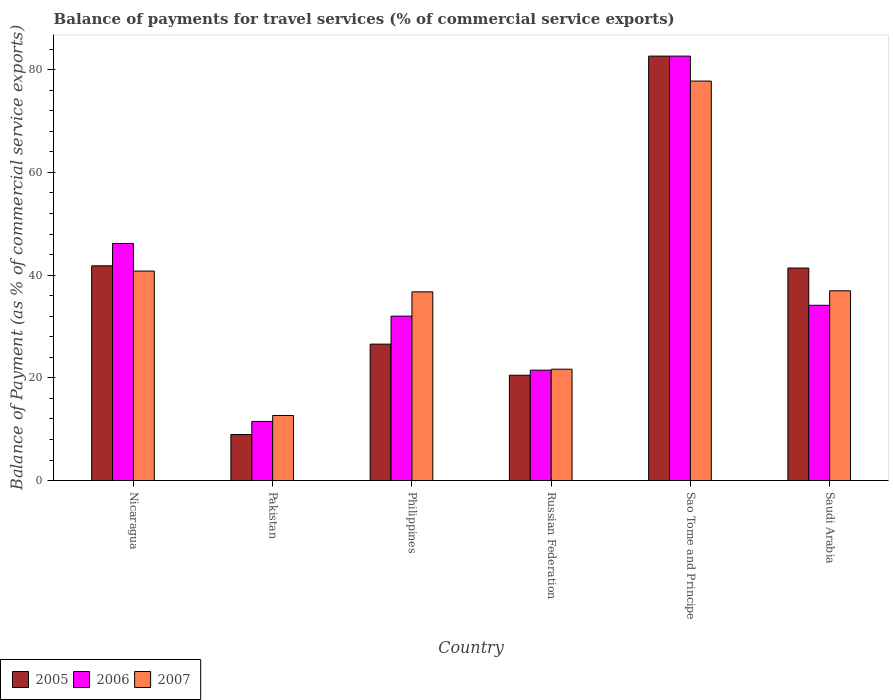How many different coloured bars are there?
Your answer should be compact. 3. How many groups of bars are there?
Ensure brevity in your answer.  6. Are the number of bars per tick equal to the number of legend labels?
Make the answer very short. Yes. How many bars are there on the 3rd tick from the left?
Offer a terse response. 3. How many bars are there on the 6th tick from the right?
Your answer should be very brief. 3. What is the label of the 1st group of bars from the left?
Provide a short and direct response. Nicaragua. In how many cases, is the number of bars for a given country not equal to the number of legend labels?
Offer a very short reply. 0. What is the balance of payments for travel services in 2005 in Saudi Arabia?
Give a very brief answer. 41.38. Across all countries, what is the maximum balance of payments for travel services in 2007?
Your answer should be very brief. 77.78. Across all countries, what is the minimum balance of payments for travel services in 2007?
Give a very brief answer. 12.67. In which country was the balance of payments for travel services in 2006 maximum?
Your answer should be compact. Sao Tome and Principe. What is the total balance of payments for travel services in 2005 in the graph?
Give a very brief answer. 221.87. What is the difference between the balance of payments for travel services in 2006 in Nicaragua and that in Pakistan?
Offer a very short reply. 34.64. What is the difference between the balance of payments for travel services in 2006 in Pakistan and the balance of payments for travel services in 2005 in Russian Federation?
Provide a short and direct response. -9. What is the average balance of payments for travel services in 2005 per country?
Your response must be concise. 36.98. What is the difference between the balance of payments for travel services of/in 2007 and balance of payments for travel services of/in 2005 in Philippines?
Your answer should be compact. 10.18. In how many countries, is the balance of payments for travel services in 2007 greater than 80 %?
Ensure brevity in your answer.  0. What is the ratio of the balance of payments for travel services in 2007 in Russian Federation to that in Saudi Arabia?
Your response must be concise. 0.59. What is the difference between the highest and the second highest balance of payments for travel services in 2005?
Provide a succinct answer. -40.83. What is the difference between the highest and the lowest balance of payments for travel services in 2005?
Give a very brief answer. 73.68. In how many countries, is the balance of payments for travel services in 2005 greater than the average balance of payments for travel services in 2005 taken over all countries?
Offer a terse response. 3. Is the sum of the balance of payments for travel services in 2005 in Philippines and Russian Federation greater than the maximum balance of payments for travel services in 2007 across all countries?
Make the answer very short. No. What does the 3rd bar from the right in Saudi Arabia represents?
Your answer should be compact. 2005. How many bars are there?
Your response must be concise. 18. Are all the bars in the graph horizontal?
Your answer should be very brief. No. What is the difference between two consecutive major ticks on the Y-axis?
Offer a terse response. 20. Are the values on the major ticks of Y-axis written in scientific E-notation?
Your answer should be compact. No. Does the graph contain any zero values?
Give a very brief answer. No. Where does the legend appear in the graph?
Provide a short and direct response. Bottom left. How many legend labels are there?
Your answer should be very brief. 3. What is the title of the graph?
Make the answer very short. Balance of payments for travel services (% of commercial service exports). What is the label or title of the Y-axis?
Ensure brevity in your answer.  Balance of Payment (as % of commercial service exports). What is the Balance of Payment (as % of commercial service exports) of 2005 in Nicaragua?
Your answer should be compact. 41.81. What is the Balance of Payment (as % of commercial service exports) of 2006 in Nicaragua?
Make the answer very short. 46.16. What is the Balance of Payment (as % of commercial service exports) of 2007 in Nicaragua?
Provide a short and direct response. 40.79. What is the Balance of Payment (as % of commercial service exports) of 2005 in Pakistan?
Your answer should be very brief. 8.97. What is the Balance of Payment (as % of commercial service exports) of 2006 in Pakistan?
Your answer should be compact. 11.51. What is the Balance of Payment (as % of commercial service exports) of 2007 in Pakistan?
Make the answer very short. 12.67. What is the Balance of Payment (as % of commercial service exports) in 2005 in Philippines?
Make the answer very short. 26.56. What is the Balance of Payment (as % of commercial service exports) of 2006 in Philippines?
Keep it short and to the point. 32.02. What is the Balance of Payment (as % of commercial service exports) in 2007 in Philippines?
Offer a very short reply. 36.74. What is the Balance of Payment (as % of commercial service exports) of 2005 in Russian Federation?
Make the answer very short. 20.51. What is the Balance of Payment (as % of commercial service exports) of 2006 in Russian Federation?
Make the answer very short. 21.5. What is the Balance of Payment (as % of commercial service exports) in 2007 in Russian Federation?
Give a very brief answer. 21.69. What is the Balance of Payment (as % of commercial service exports) of 2005 in Sao Tome and Principe?
Offer a very short reply. 82.64. What is the Balance of Payment (as % of commercial service exports) of 2006 in Sao Tome and Principe?
Ensure brevity in your answer.  82.64. What is the Balance of Payment (as % of commercial service exports) in 2007 in Sao Tome and Principe?
Your answer should be compact. 77.78. What is the Balance of Payment (as % of commercial service exports) in 2005 in Saudi Arabia?
Your answer should be compact. 41.38. What is the Balance of Payment (as % of commercial service exports) of 2006 in Saudi Arabia?
Offer a terse response. 34.13. What is the Balance of Payment (as % of commercial service exports) of 2007 in Saudi Arabia?
Your answer should be compact. 36.95. Across all countries, what is the maximum Balance of Payment (as % of commercial service exports) in 2005?
Your answer should be very brief. 82.64. Across all countries, what is the maximum Balance of Payment (as % of commercial service exports) in 2006?
Your answer should be very brief. 82.64. Across all countries, what is the maximum Balance of Payment (as % of commercial service exports) of 2007?
Give a very brief answer. 77.78. Across all countries, what is the minimum Balance of Payment (as % of commercial service exports) of 2005?
Offer a terse response. 8.97. Across all countries, what is the minimum Balance of Payment (as % of commercial service exports) in 2006?
Ensure brevity in your answer.  11.51. Across all countries, what is the minimum Balance of Payment (as % of commercial service exports) in 2007?
Provide a short and direct response. 12.67. What is the total Balance of Payment (as % of commercial service exports) of 2005 in the graph?
Give a very brief answer. 221.87. What is the total Balance of Payment (as % of commercial service exports) of 2006 in the graph?
Your response must be concise. 227.95. What is the total Balance of Payment (as % of commercial service exports) of 2007 in the graph?
Make the answer very short. 226.63. What is the difference between the Balance of Payment (as % of commercial service exports) in 2005 in Nicaragua and that in Pakistan?
Offer a terse response. 32.85. What is the difference between the Balance of Payment (as % of commercial service exports) of 2006 in Nicaragua and that in Pakistan?
Provide a short and direct response. 34.64. What is the difference between the Balance of Payment (as % of commercial service exports) in 2007 in Nicaragua and that in Pakistan?
Offer a terse response. 28.12. What is the difference between the Balance of Payment (as % of commercial service exports) of 2005 in Nicaragua and that in Philippines?
Provide a short and direct response. 15.25. What is the difference between the Balance of Payment (as % of commercial service exports) of 2006 in Nicaragua and that in Philippines?
Offer a terse response. 14.14. What is the difference between the Balance of Payment (as % of commercial service exports) in 2007 in Nicaragua and that in Philippines?
Provide a succinct answer. 4.05. What is the difference between the Balance of Payment (as % of commercial service exports) of 2005 in Nicaragua and that in Russian Federation?
Provide a short and direct response. 21.3. What is the difference between the Balance of Payment (as % of commercial service exports) of 2006 in Nicaragua and that in Russian Federation?
Provide a short and direct response. 24.66. What is the difference between the Balance of Payment (as % of commercial service exports) in 2007 in Nicaragua and that in Russian Federation?
Offer a terse response. 19.1. What is the difference between the Balance of Payment (as % of commercial service exports) of 2005 in Nicaragua and that in Sao Tome and Principe?
Ensure brevity in your answer.  -40.83. What is the difference between the Balance of Payment (as % of commercial service exports) in 2006 in Nicaragua and that in Sao Tome and Principe?
Your answer should be very brief. -36.49. What is the difference between the Balance of Payment (as % of commercial service exports) of 2007 in Nicaragua and that in Sao Tome and Principe?
Offer a terse response. -36.99. What is the difference between the Balance of Payment (as % of commercial service exports) of 2005 in Nicaragua and that in Saudi Arabia?
Ensure brevity in your answer.  0.43. What is the difference between the Balance of Payment (as % of commercial service exports) of 2006 in Nicaragua and that in Saudi Arabia?
Keep it short and to the point. 12.03. What is the difference between the Balance of Payment (as % of commercial service exports) in 2007 in Nicaragua and that in Saudi Arabia?
Provide a short and direct response. 3.84. What is the difference between the Balance of Payment (as % of commercial service exports) of 2005 in Pakistan and that in Philippines?
Ensure brevity in your answer.  -17.6. What is the difference between the Balance of Payment (as % of commercial service exports) of 2006 in Pakistan and that in Philippines?
Your answer should be very brief. -20.5. What is the difference between the Balance of Payment (as % of commercial service exports) of 2007 in Pakistan and that in Philippines?
Give a very brief answer. -24.07. What is the difference between the Balance of Payment (as % of commercial service exports) of 2005 in Pakistan and that in Russian Federation?
Give a very brief answer. -11.55. What is the difference between the Balance of Payment (as % of commercial service exports) in 2006 in Pakistan and that in Russian Federation?
Your answer should be compact. -9.98. What is the difference between the Balance of Payment (as % of commercial service exports) of 2007 in Pakistan and that in Russian Federation?
Keep it short and to the point. -9.01. What is the difference between the Balance of Payment (as % of commercial service exports) of 2005 in Pakistan and that in Sao Tome and Principe?
Offer a very short reply. -73.68. What is the difference between the Balance of Payment (as % of commercial service exports) of 2006 in Pakistan and that in Sao Tome and Principe?
Your answer should be very brief. -71.13. What is the difference between the Balance of Payment (as % of commercial service exports) of 2007 in Pakistan and that in Sao Tome and Principe?
Offer a very short reply. -65.11. What is the difference between the Balance of Payment (as % of commercial service exports) in 2005 in Pakistan and that in Saudi Arabia?
Ensure brevity in your answer.  -32.41. What is the difference between the Balance of Payment (as % of commercial service exports) in 2006 in Pakistan and that in Saudi Arabia?
Your answer should be very brief. -22.61. What is the difference between the Balance of Payment (as % of commercial service exports) of 2007 in Pakistan and that in Saudi Arabia?
Provide a succinct answer. -24.28. What is the difference between the Balance of Payment (as % of commercial service exports) in 2005 in Philippines and that in Russian Federation?
Make the answer very short. 6.05. What is the difference between the Balance of Payment (as % of commercial service exports) of 2006 in Philippines and that in Russian Federation?
Provide a succinct answer. 10.52. What is the difference between the Balance of Payment (as % of commercial service exports) in 2007 in Philippines and that in Russian Federation?
Make the answer very short. 15.06. What is the difference between the Balance of Payment (as % of commercial service exports) of 2005 in Philippines and that in Sao Tome and Principe?
Offer a terse response. -56.08. What is the difference between the Balance of Payment (as % of commercial service exports) in 2006 in Philippines and that in Sao Tome and Principe?
Your answer should be compact. -50.63. What is the difference between the Balance of Payment (as % of commercial service exports) in 2007 in Philippines and that in Sao Tome and Principe?
Make the answer very short. -41.04. What is the difference between the Balance of Payment (as % of commercial service exports) of 2005 in Philippines and that in Saudi Arabia?
Your answer should be compact. -14.81. What is the difference between the Balance of Payment (as % of commercial service exports) of 2006 in Philippines and that in Saudi Arabia?
Keep it short and to the point. -2.11. What is the difference between the Balance of Payment (as % of commercial service exports) of 2007 in Philippines and that in Saudi Arabia?
Your answer should be very brief. -0.21. What is the difference between the Balance of Payment (as % of commercial service exports) of 2005 in Russian Federation and that in Sao Tome and Principe?
Offer a terse response. -62.13. What is the difference between the Balance of Payment (as % of commercial service exports) in 2006 in Russian Federation and that in Sao Tome and Principe?
Your answer should be very brief. -61.15. What is the difference between the Balance of Payment (as % of commercial service exports) of 2007 in Russian Federation and that in Sao Tome and Principe?
Provide a short and direct response. -56.1. What is the difference between the Balance of Payment (as % of commercial service exports) of 2005 in Russian Federation and that in Saudi Arabia?
Offer a terse response. -20.87. What is the difference between the Balance of Payment (as % of commercial service exports) of 2006 in Russian Federation and that in Saudi Arabia?
Provide a succinct answer. -12.63. What is the difference between the Balance of Payment (as % of commercial service exports) in 2007 in Russian Federation and that in Saudi Arabia?
Make the answer very short. -15.27. What is the difference between the Balance of Payment (as % of commercial service exports) of 2005 in Sao Tome and Principe and that in Saudi Arabia?
Provide a succinct answer. 41.26. What is the difference between the Balance of Payment (as % of commercial service exports) in 2006 in Sao Tome and Principe and that in Saudi Arabia?
Make the answer very short. 48.52. What is the difference between the Balance of Payment (as % of commercial service exports) in 2007 in Sao Tome and Principe and that in Saudi Arabia?
Offer a very short reply. 40.83. What is the difference between the Balance of Payment (as % of commercial service exports) of 2005 in Nicaragua and the Balance of Payment (as % of commercial service exports) of 2006 in Pakistan?
Give a very brief answer. 30.3. What is the difference between the Balance of Payment (as % of commercial service exports) of 2005 in Nicaragua and the Balance of Payment (as % of commercial service exports) of 2007 in Pakistan?
Offer a very short reply. 29.14. What is the difference between the Balance of Payment (as % of commercial service exports) of 2006 in Nicaragua and the Balance of Payment (as % of commercial service exports) of 2007 in Pakistan?
Offer a terse response. 33.48. What is the difference between the Balance of Payment (as % of commercial service exports) of 2005 in Nicaragua and the Balance of Payment (as % of commercial service exports) of 2006 in Philippines?
Your answer should be very brief. 9.8. What is the difference between the Balance of Payment (as % of commercial service exports) of 2005 in Nicaragua and the Balance of Payment (as % of commercial service exports) of 2007 in Philippines?
Keep it short and to the point. 5.07. What is the difference between the Balance of Payment (as % of commercial service exports) in 2006 in Nicaragua and the Balance of Payment (as % of commercial service exports) in 2007 in Philippines?
Provide a succinct answer. 9.41. What is the difference between the Balance of Payment (as % of commercial service exports) in 2005 in Nicaragua and the Balance of Payment (as % of commercial service exports) in 2006 in Russian Federation?
Provide a succinct answer. 20.31. What is the difference between the Balance of Payment (as % of commercial service exports) in 2005 in Nicaragua and the Balance of Payment (as % of commercial service exports) in 2007 in Russian Federation?
Ensure brevity in your answer.  20.13. What is the difference between the Balance of Payment (as % of commercial service exports) in 2006 in Nicaragua and the Balance of Payment (as % of commercial service exports) in 2007 in Russian Federation?
Your answer should be compact. 24.47. What is the difference between the Balance of Payment (as % of commercial service exports) in 2005 in Nicaragua and the Balance of Payment (as % of commercial service exports) in 2006 in Sao Tome and Principe?
Offer a terse response. -40.83. What is the difference between the Balance of Payment (as % of commercial service exports) in 2005 in Nicaragua and the Balance of Payment (as % of commercial service exports) in 2007 in Sao Tome and Principe?
Offer a terse response. -35.97. What is the difference between the Balance of Payment (as % of commercial service exports) of 2006 in Nicaragua and the Balance of Payment (as % of commercial service exports) of 2007 in Sao Tome and Principe?
Your answer should be very brief. -31.63. What is the difference between the Balance of Payment (as % of commercial service exports) of 2005 in Nicaragua and the Balance of Payment (as % of commercial service exports) of 2006 in Saudi Arabia?
Provide a succinct answer. 7.68. What is the difference between the Balance of Payment (as % of commercial service exports) of 2005 in Nicaragua and the Balance of Payment (as % of commercial service exports) of 2007 in Saudi Arabia?
Your answer should be compact. 4.86. What is the difference between the Balance of Payment (as % of commercial service exports) of 2006 in Nicaragua and the Balance of Payment (as % of commercial service exports) of 2007 in Saudi Arabia?
Offer a terse response. 9.21. What is the difference between the Balance of Payment (as % of commercial service exports) of 2005 in Pakistan and the Balance of Payment (as % of commercial service exports) of 2006 in Philippines?
Provide a short and direct response. -23.05. What is the difference between the Balance of Payment (as % of commercial service exports) of 2005 in Pakistan and the Balance of Payment (as % of commercial service exports) of 2007 in Philippines?
Give a very brief answer. -27.78. What is the difference between the Balance of Payment (as % of commercial service exports) in 2006 in Pakistan and the Balance of Payment (as % of commercial service exports) in 2007 in Philippines?
Offer a very short reply. -25.23. What is the difference between the Balance of Payment (as % of commercial service exports) in 2005 in Pakistan and the Balance of Payment (as % of commercial service exports) in 2006 in Russian Federation?
Your answer should be very brief. -12.53. What is the difference between the Balance of Payment (as % of commercial service exports) of 2005 in Pakistan and the Balance of Payment (as % of commercial service exports) of 2007 in Russian Federation?
Your answer should be very brief. -12.72. What is the difference between the Balance of Payment (as % of commercial service exports) of 2006 in Pakistan and the Balance of Payment (as % of commercial service exports) of 2007 in Russian Federation?
Your response must be concise. -10.17. What is the difference between the Balance of Payment (as % of commercial service exports) of 2005 in Pakistan and the Balance of Payment (as % of commercial service exports) of 2006 in Sao Tome and Principe?
Make the answer very short. -73.68. What is the difference between the Balance of Payment (as % of commercial service exports) of 2005 in Pakistan and the Balance of Payment (as % of commercial service exports) of 2007 in Sao Tome and Principe?
Offer a terse response. -68.82. What is the difference between the Balance of Payment (as % of commercial service exports) of 2006 in Pakistan and the Balance of Payment (as % of commercial service exports) of 2007 in Sao Tome and Principe?
Your answer should be compact. -66.27. What is the difference between the Balance of Payment (as % of commercial service exports) in 2005 in Pakistan and the Balance of Payment (as % of commercial service exports) in 2006 in Saudi Arabia?
Offer a very short reply. -25.16. What is the difference between the Balance of Payment (as % of commercial service exports) of 2005 in Pakistan and the Balance of Payment (as % of commercial service exports) of 2007 in Saudi Arabia?
Your answer should be compact. -27.99. What is the difference between the Balance of Payment (as % of commercial service exports) in 2006 in Pakistan and the Balance of Payment (as % of commercial service exports) in 2007 in Saudi Arabia?
Offer a terse response. -25.44. What is the difference between the Balance of Payment (as % of commercial service exports) of 2005 in Philippines and the Balance of Payment (as % of commercial service exports) of 2006 in Russian Federation?
Offer a very short reply. 5.07. What is the difference between the Balance of Payment (as % of commercial service exports) of 2005 in Philippines and the Balance of Payment (as % of commercial service exports) of 2007 in Russian Federation?
Ensure brevity in your answer.  4.88. What is the difference between the Balance of Payment (as % of commercial service exports) of 2006 in Philippines and the Balance of Payment (as % of commercial service exports) of 2007 in Russian Federation?
Your answer should be compact. 10.33. What is the difference between the Balance of Payment (as % of commercial service exports) in 2005 in Philippines and the Balance of Payment (as % of commercial service exports) in 2006 in Sao Tome and Principe?
Make the answer very short. -56.08. What is the difference between the Balance of Payment (as % of commercial service exports) of 2005 in Philippines and the Balance of Payment (as % of commercial service exports) of 2007 in Sao Tome and Principe?
Your answer should be compact. -51.22. What is the difference between the Balance of Payment (as % of commercial service exports) of 2006 in Philippines and the Balance of Payment (as % of commercial service exports) of 2007 in Sao Tome and Principe?
Offer a very short reply. -45.77. What is the difference between the Balance of Payment (as % of commercial service exports) of 2005 in Philippines and the Balance of Payment (as % of commercial service exports) of 2006 in Saudi Arabia?
Your answer should be very brief. -7.56. What is the difference between the Balance of Payment (as % of commercial service exports) in 2005 in Philippines and the Balance of Payment (as % of commercial service exports) in 2007 in Saudi Arabia?
Ensure brevity in your answer.  -10.39. What is the difference between the Balance of Payment (as % of commercial service exports) of 2006 in Philippines and the Balance of Payment (as % of commercial service exports) of 2007 in Saudi Arabia?
Give a very brief answer. -4.94. What is the difference between the Balance of Payment (as % of commercial service exports) in 2005 in Russian Federation and the Balance of Payment (as % of commercial service exports) in 2006 in Sao Tome and Principe?
Offer a very short reply. -62.13. What is the difference between the Balance of Payment (as % of commercial service exports) of 2005 in Russian Federation and the Balance of Payment (as % of commercial service exports) of 2007 in Sao Tome and Principe?
Your response must be concise. -57.27. What is the difference between the Balance of Payment (as % of commercial service exports) of 2006 in Russian Federation and the Balance of Payment (as % of commercial service exports) of 2007 in Sao Tome and Principe?
Your answer should be compact. -56.29. What is the difference between the Balance of Payment (as % of commercial service exports) of 2005 in Russian Federation and the Balance of Payment (as % of commercial service exports) of 2006 in Saudi Arabia?
Your response must be concise. -13.61. What is the difference between the Balance of Payment (as % of commercial service exports) in 2005 in Russian Federation and the Balance of Payment (as % of commercial service exports) in 2007 in Saudi Arabia?
Your answer should be very brief. -16.44. What is the difference between the Balance of Payment (as % of commercial service exports) of 2006 in Russian Federation and the Balance of Payment (as % of commercial service exports) of 2007 in Saudi Arabia?
Ensure brevity in your answer.  -15.45. What is the difference between the Balance of Payment (as % of commercial service exports) in 2005 in Sao Tome and Principe and the Balance of Payment (as % of commercial service exports) in 2006 in Saudi Arabia?
Provide a succinct answer. 48.52. What is the difference between the Balance of Payment (as % of commercial service exports) in 2005 in Sao Tome and Principe and the Balance of Payment (as % of commercial service exports) in 2007 in Saudi Arabia?
Keep it short and to the point. 45.69. What is the difference between the Balance of Payment (as % of commercial service exports) in 2006 in Sao Tome and Principe and the Balance of Payment (as % of commercial service exports) in 2007 in Saudi Arabia?
Offer a terse response. 45.69. What is the average Balance of Payment (as % of commercial service exports) in 2005 per country?
Offer a very short reply. 36.98. What is the average Balance of Payment (as % of commercial service exports) in 2006 per country?
Your answer should be compact. 37.99. What is the average Balance of Payment (as % of commercial service exports) in 2007 per country?
Ensure brevity in your answer.  37.77. What is the difference between the Balance of Payment (as % of commercial service exports) of 2005 and Balance of Payment (as % of commercial service exports) of 2006 in Nicaragua?
Offer a very short reply. -4.34. What is the difference between the Balance of Payment (as % of commercial service exports) of 2006 and Balance of Payment (as % of commercial service exports) of 2007 in Nicaragua?
Offer a very short reply. 5.37. What is the difference between the Balance of Payment (as % of commercial service exports) of 2005 and Balance of Payment (as % of commercial service exports) of 2006 in Pakistan?
Ensure brevity in your answer.  -2.55. What is the difference between the Balance of Payment (as % of commercial service exports) of 2005 and Balance of Payment (as % of commercial service exports) of 2007 in Pakistan?
Keep it short and to the point. -3.71. What is the difference between the Balance of Payment (as % of commercial service exports) of 2006 and Balance of Payment (as % of commercial service exports) of 2007 in Pakistan?
Your answer should be very brief. -1.16. What is the difference between the Balance of Payment (as % of commercial service exports) in 2005 and Balance of Payment (as % of commercial service exports) in 2006 in Philippines?
Your answer should be compact. -5.45. What is the difference between the Balance of Payment (as % of commercial service exports) of 2005 and Balance of Payment (as % of commercial service exports) of 2007 in Philippines?
Offer a terse response. -10.18. What is the difference between the Balance of Payment (as % of commercial service exports) in 2006 and Balance of Payment (as % of commercial service exports) in 2007 in Philippines?
Your answer should be compact. -4.73. What is the difference between the Balance of Payment (as % of commercial service exports) in 2005 and Balance of Payment (as % of commercial service exports) in 2006 in Russian Federation?
Make the answer very short. -0.99. What is the difference between the Balance of Payment (as % of commercial service exports) in 2005 and Balance of Payment (as % of commercial service exports) in 2007 in Russian Federation?
Make the answer very short. -1.17. What is the difference between the Balance of Payment (as % of commercial service exports) of 2006 and Balance of Payment (as % of commercial service exports) of 2007 in Russian Federation?
Keep it short and to the point. -0.19. What is the difference between the Balance of Payment (as % of commercial service exports) in 2005 and Balance of Payment (as % of commercial service exports) in 2006 in Sao Tome and Principe?
Your response must be concise. -0. What is the difference between the Balance of Payment (as % of commercial service exports) in 2005 and Balance of Payment (as % of commercial service exports) in 2007 in Sao Tome and Principe?
Make the answer very short. 4.86. What is the difference between the Balance of Payment (as % of commercial service exports) of 2006 and Balance of Payment (as % of commercial service exports) of 2007 in Sao Tome and Principe?
Ensure brevity in your answer.  4.86. What is the difference between the Balance of Payment (as % of commercial service exports) in 2005 and Balance of Payment (as % of commercial service exports) in 2006 in Saudi Arabia?
Your response must be concise. 7.25. What is the difference between the Balance of Payment (as % of commercial service exports) of 2005 and Balance of Payment (as % of commercial service exports) of 2007 in Saudi Arabia?
Offer a very short reply. 4.43. What is the difference between the Balance of Payment (as % of commercial service exports) in 2006 and Balance of Payment (as % of commercial service exports) in 2007 in Saudi Arabia?
Provide a short and direct response. -2.82. What is the ratio of the Balance of Payment (as % of commercial service exports) in 2005 in Nicaragua to that in Pakistan?
Offer a terse response. 4.66. What is the ratio of the Balance of Payment (as % of commercial service exports) of 2006 in Nicaragua to that in Pakistan?
Give a very brief answer. 4.01. What is the ratio of the Balance of Payment (as % of commercial service exports) in 2007 in Nicaragua to that in Pakistan?
Provide a succinct answer. 3.22. What is the ratio of the Balance of Payment (as % of commercial service exports) in 2005 in Nicaragua to that in Philippines?
Your answer should be very brief. 1.57. What is the ratio of the Balance of Payment (as % of commercial service exports) in 2006 in Nicaragua to that in Philippines?
Give a very brief answer. 1.44. What is the ratio of the Balance of Payment (as % of commercial service exports) of 2007 in Nicaragua to that in Philippines?
Give a very brief answer. 1.11. What is the ratio of the Balance of Payment (as % of commercial service exports) of 2005 in Nicaragua to that in Russian Federation?
Your answer should be very brief. 2.04. What is the ratio of the Balance of Payment (as % of commercial service exports) of 2006 in Nicaragua to that in Russian Federation?
Ensure brevity in your answer.  2.15. What is the ratio of the Balance of Payment (as % of commercial service exports) in 2007 in Nicaragua to that in Russian Federation?
Keep it short and to the point. 1.88. What is the ratio of the Balance of Payment (as % of commercial service exports) of 2005 in Nicaragua to that in Sao Tome and Principe?
Your answer should be compact. 0.51. What is the ratio of the Balance of Payment (as % of commercial service exports) of 2006 in Nicaragua to that in Sao Tome and Principe?
Provide a succinct answer. 0.56. What is the ratio of the Balance of Payment (as % of commercial service exports) of 2007 in Nicaragua to that in Sao Tome and Principe?
Your answer should be very brief. 0.52. What is the ratio of the Balance of Payment (as % of commercial service exports) in 2005 in Nicaragua to that in Saudi Arabia?
Offer a very short reply. 1.01. What is the ratio of the Balance of Payment (as % of commercial service exports) in 2006 in Nicaragua to that in Saudi Arabia?
Keep it short and to the point. 1.35. What is the ratio of the Balance of Payment (as % of commercial service exports) in 2007 in Nicaragua to that in Saudi Arabia?
Keep it short and to the point. 1.1. What is the ratio of the Balance of Payment (as % of commercial service exports) of 2005 in Pakistan to that in Philippines?
Ensure brevity in your answer.  0.34. What is the ratio of the Balance of Payment (as % of commercial service exports) in 2006 in Pakistan to that in Philippines?
Offer a terse response. 0.36. What is the ratio of the Balance of Payment (as % of commercial service exports) of 2007 in Pakistan to that in Philippines?
Provide a succinct answer. 0.34. What is the ratio of the Balance of Payment (as % of commercial service exports) in 2005 in Pakistan to that in Russian Federation?
Offer a very short reply. 0.44. What is the ratio of the Balance of Payment (as % of commercial service exports) of 2006 in Pakistan to that in Russian Federation?
Offer a very short reply. 0.54. What is the ratio of the Balance of Payment (as % of commercial service exports) of 2007 in Pakistan to that in Russian Federation?
Ensure brevity in your answer.  0.58. What is the ratio of the Balance of Payment (as % of commercial service exports) of 2005 in Pakistan to that in Sao Tome and Principe?
Your response must be concise. 0.11. What is the ratio of the Balance of Payment (as % of commercial service exports) of 2006 in Pakistan to that in Sao Tome and Principe?
Offer a terse response. 0.14. What is the ratio of the Balance of Payment (as % of commercial service exports) of 2007 in Pakistan to that in Sao Tome and Principe?
Keep it short and to the point. 0.16. What is the ratio of the Balance of Payment (as % of commercial service exports) of 2005 in Pakistan to that in Saudi Arabia?
Ensure brevity in your answer.  0.22. What is the ratio of the Balance of Payment (as % of commercial service exports) of 2006 in Pakistan to that in Saudi Arabia?
Provide a succinct answer. 0.34. What is the ratio of the Balance of Payment (as % of commercial service exports) of 2007 in Pakistan to that in Saudi Arabia?
Offer a very short reply. 0.34. What is the ratio of the Balance of Payment (as % of commercial service exports) in 2005 in Philippines to that in Russian Federation?
Your answer should be compact. 1.3. What is the ratio of the Balance of Payment (as % of commercial service exports) of 2006 in Philippines to that in Russian Federation?
Your answer should be very brief. 1.49. What is the ratio of the Balance of Payment (as % of commercial service exports) of 2007 in Philippines to that in Russian Federation?
Ensure brevity in your answer.  1.69. What is the ratio of the Balance of Payment (as % of commercial service exports) in 2005 in Philippines to that in Sao Tome and Principe?
Make the answer very short. 0.32. What is the ratio of the Balance of Payment (as % of commercial service exports) of 2006 in Philippines to that in Sao Tome and Principe?
Offer a terse response. 0.39. What is the ratio of the Balance of Payment (as % of commercial service exports) in 2007 in Philippines to that in Sao Tome and Principe?
Provide a succinct answer. 0.47. What is the ratio of the Balance of Payment (as % of commercial service exports) of 2005 in Philippines to that in Saudi Arabia?
Your answer should be very brief. 0.64. What is the ratio of the Balance of Payment (as % of commercial service exports) of 2006 in Philippines to that in Saudi Arabia?
Ensure brevity in your answer.  0.94. What is the ratio of the Balance of Payment (as % of commercial service exports) of 2005 in Russian Federation to that in Sao Tome and Principe?
Offer a terse response. 0.25. What is the ratio of the Balance of Payment (as % of commercial service exports) of 2006 in Russian Federation to that in Sao Tome and Principe?
Your answer should be compact. 0.26. What is the ratio of the Balance of Payment (as % of commercial service exports) in 2007 in Russian Federation to that in Sao Tome and Principe?
Keep it short and to the point. 0.28. What is the ratio of the Balance of Payment (as % of commercial service exports) in 2005 in Russian Federation to that in Saudi Arabia?
Provide a short and direct response. 0.5. What is the ratio of the Balance of Payment (as % of commercial service exports) in 2006 in Russian Federation to that in Saudi Arabia?
Give a very brief answer. 0.63. What is the ratio of the Balance of Payment (as % of commercial service exports) of 2007 in Russian Federation to that in Saudi Arabia?
Your answer should be very brief. 0.59. What is the ratio of the Balance of Payment (as % of commercial service exports) of 2005 in Sao Tome and Principe to that in Saudi Arabia?
Ensure brevity in your answer.  2. What is the ratio of the Balance of Payment (as % of commercial service exports) in 2006 in Sao Tome and Principe to that in Saudi Arabia?
Offer a very short reply. 2.42. What is the ratio of the Balance of Payment (as % of commercial service exports) in 2007 in Sao Tome and Principe to that in Saudi Arabia?
Give a very brief answer. 2.1. What is the difference between the highest and the second highest Balance of Payment (as % of commercial service exports) of 2005?
Make the answer very short. 40.83. What is the difference between the highest and the second highest Balance of Payment (as % of commercial service exports) of 2006?
Give a very brief answer. 36.49. What is the difference between the highest and the second highest Balance of Payment (as % of commercial service exports) of 2007?
Your answer should be compact. 36.99. What is the difference between the highest and the lowest Balance of Payment (as % of commercial service exports) of 2005?
Provide a short and direct response. 73.68. What is the difference between the highest and the lowest Balance of Payment (as % of commercial service exports) of 2006?
Offer a terse response. 71.13. What is the difference between the highest and the lowest Balance of Payment (as % of commercial service exports) of 2007?
Provide a succinct answer. 65.11. 